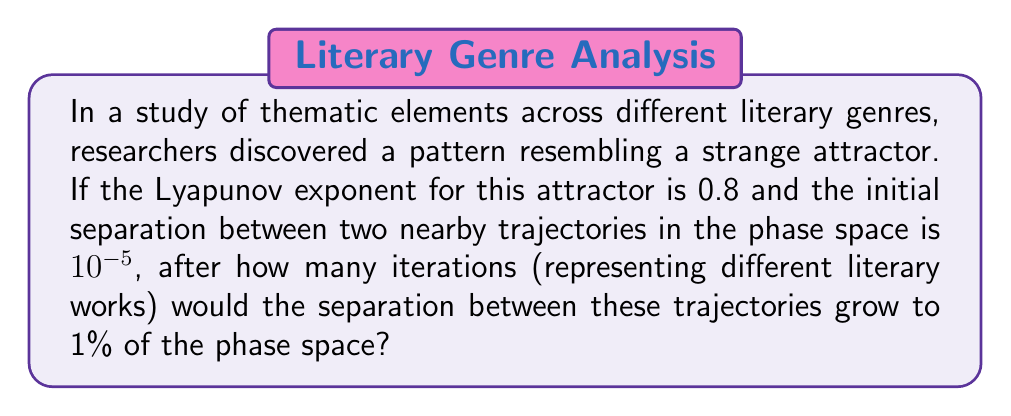What is the answer to this math problem? To solve this problem, we'll use the concept of Lyapunov exponents and their relationship to the divergence of nearby trajectories in a chaotic system. Let's approach this step-by-step:

1) The Lyapunov exponent (λ) measures the rate of separation of infinitesimally close trajectories. In this case, λ = 0.8.

2) The general formula for the separation of trajectories over time is:

   $$d(t) = d_0 e^{\lambda t}$$

   Where $d(t)$ is the separation at time t, $d_0$ is the initial separation, and t is the number of iterations.

3) We're given:
   - Initial separation $d_0 = 10^{-5}$
   - Final separation $d(t) = 0.01$ (1% of phase space)
   - Lyapunov exponent λ = 0.8

4) Substituting these into our equation:

   $$0.01 = 10^{-5} e^{0.8t}$$

5) Now, let's solve for t:

   $$\frac{0.01}{10^{-5}} = e^{0.8t}$$
   $$1000 = e^{0.8t}$$

6) Taking the natural log of both sides:

   $$\ln(1000) = 0.8t$$

7) Solving for t:

   $$t = \frac{\ln(1000)}{0.8} \approx 8.63$$

8) Since we're dealing with iterations (which must be whole numbers), we round up to the next integer.

Therefore, it would take 9 iterations for the separation to grow to 1% of the phase space.
Answer: 9 iterations 